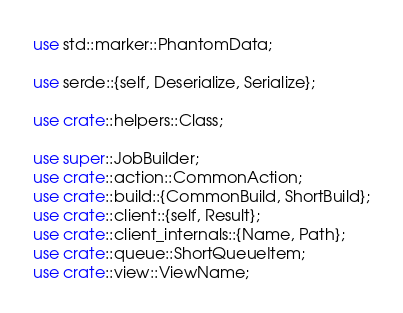Convert code to text. <code><loc_0><loc_0><loc_500><loc_500><_Rust_>use std::marker::PhantomData;

use serde::{self, Deserialize, Serialize};

use crate::helpers::Class;

use super::JobBuilder;
use crate::action::CommonAction;
use crate::build::{CommonBuild, ShortBuild};
use crate::client::{self, Result};
use crate::client_internals::{Name, Path};
use crate::queue::ShortQueueItem;
use crate::view::ViewName;</code> 